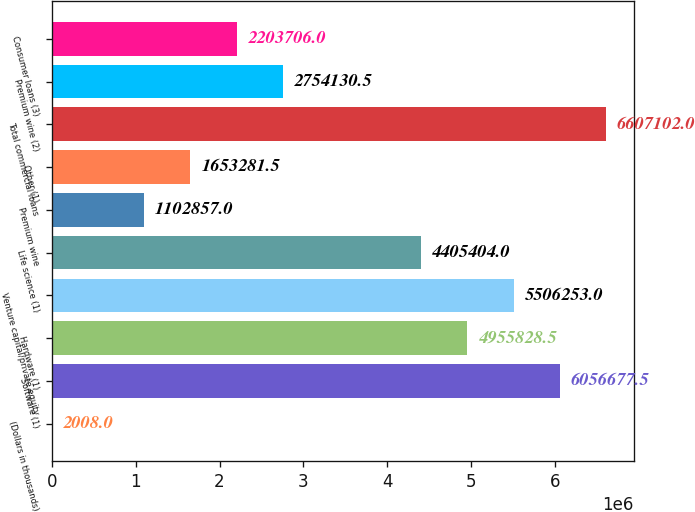<chart> <loc_0><loc_0><loc_500><loc_500><bar_chart><fcel>(Dollars in thousands)<fcel>Software (1)<fcel>Hardware (1)<fcel>Venture capital/private equity<fcel>Life science (1)<fcel>Premium wine<fcel>Other (1)<fcel>Total commercial loans<fcel>Premium wine (2)<fcel>Consumer loans (3)<nl><fcel>2008<fcel>6.05668e+06<fcel>4.95583e+06<fcel>5.50625e+06<fcel>4.4054e+06<fcel>1.10286e+06<fcel>1.65328e+06<fcel>6.6071e+06<fcel>2.75413e+06<fcel>2.20371e+06<nl></chart> 